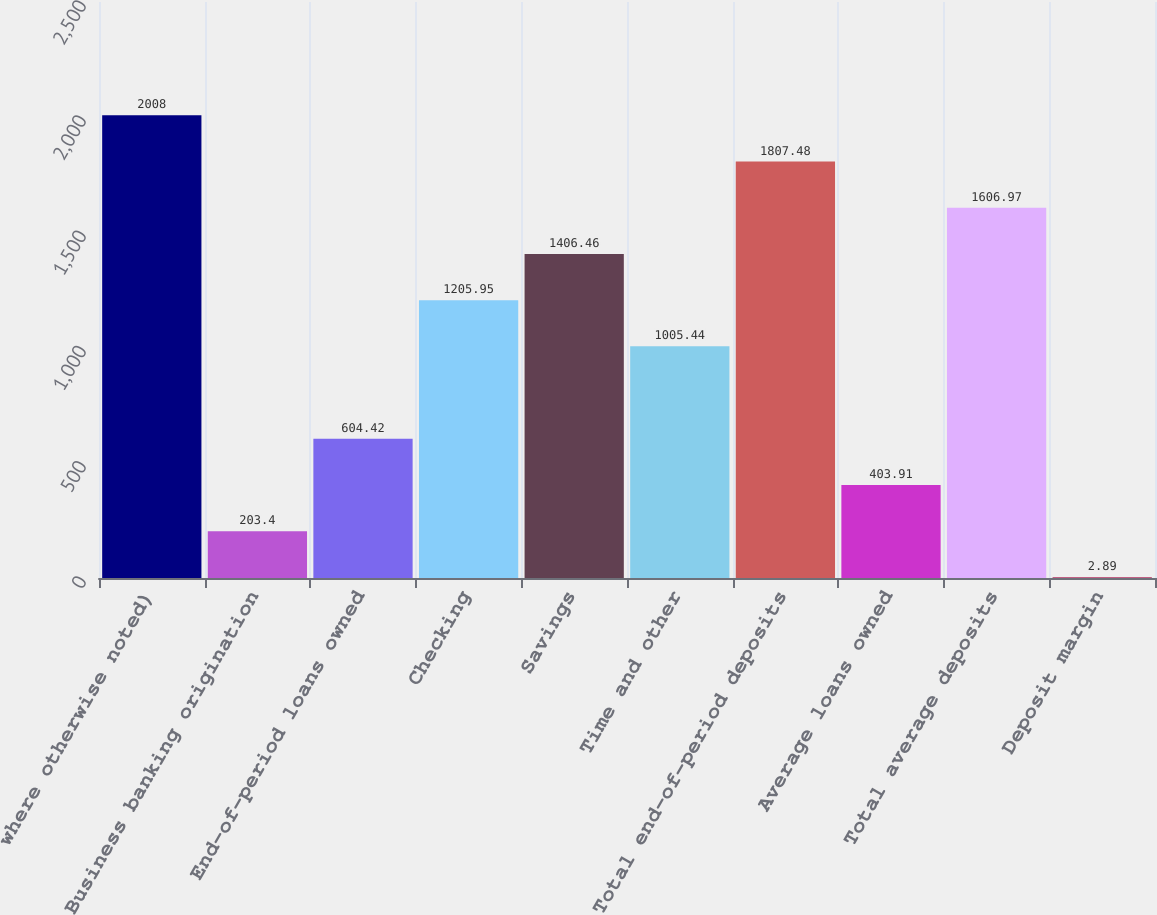<chart> <loc_0><loc_0><loc_500><loc_500><bar_chart><fcel>where otherwise noted)<fcel>Business banking origination<fcel>End-of-period loans owned<fcel>Checking<fcel>Savings<fcel>Time and other<fcel>Total end-of-period deposits<fcel>Average loans owned<fcel>Total average deposits<fcel>Deposit margin<nl><fcel>2008<fcel>203.4<fcel>604.42<fcel>1205.95<fcel>1406.46<fcel>1005.44<fcel>1807.48<fcel>403.91<fcel>1606.97<fcel>2.89<nl></chart> 